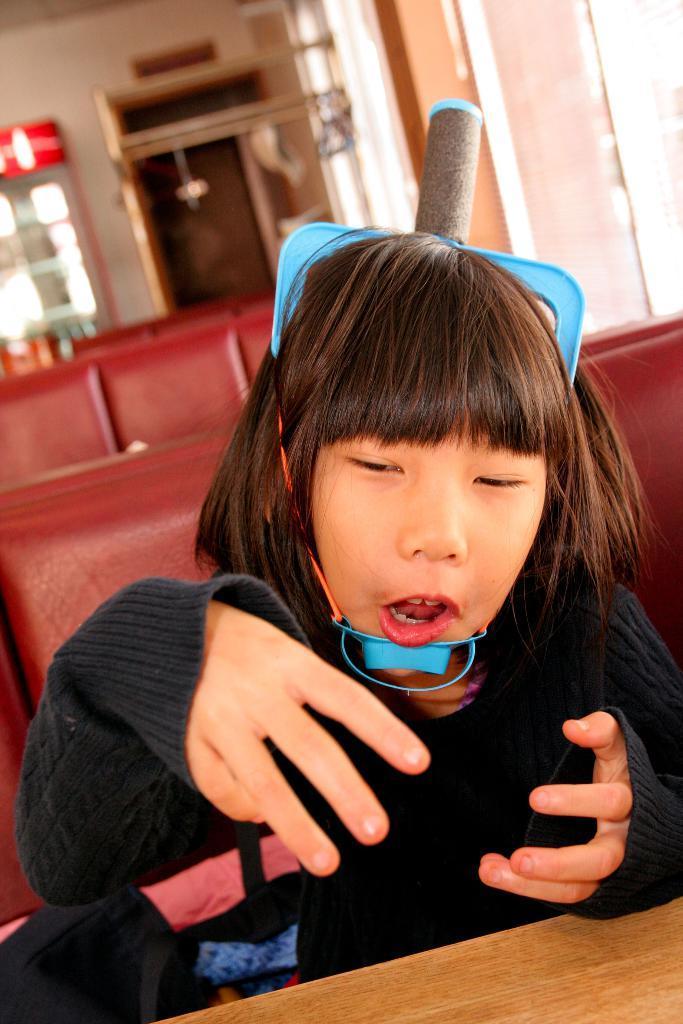Can you describe this image briefly? In this image there is a girl sitting on the chair and she is holding some object. In front of her there is a table. Behind her there are chairs. In the background of the image there is a wall. In front of the wall there is some object. 